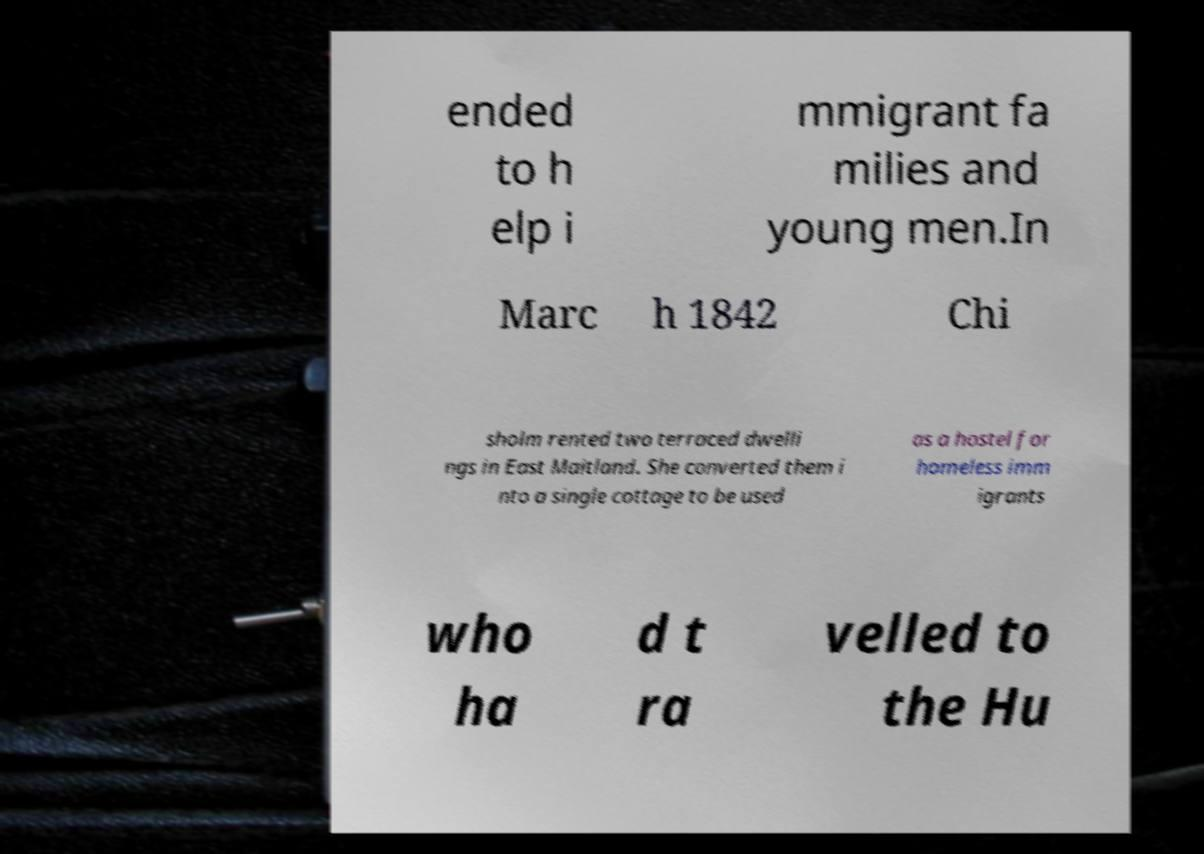Please read and relay the text visible in this image. What does it say? ended to h elp i mmigrant fa milies and young men.In Marc h 1842 Chi sholm rented two terraced dwelli ngs in East Maitland. She converted them i nto a single cottage to be used as a hostel for homeless imm igrants who ha d t ra velled to the Hu 